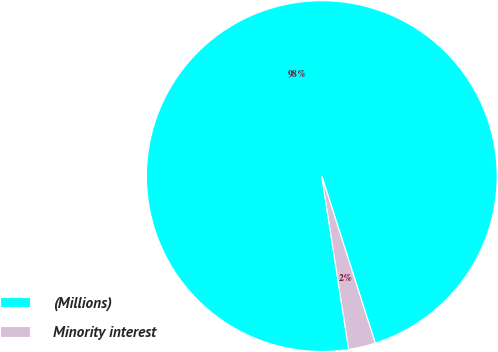Convert chart to OTSL. <chart><loc_0><loc_0><loc_500><loc_500><pie_chart><fcel>(Millions)<fcel>Minority interest<nl><fcel>97.52%<fcel>2.48%<nl></chart> 